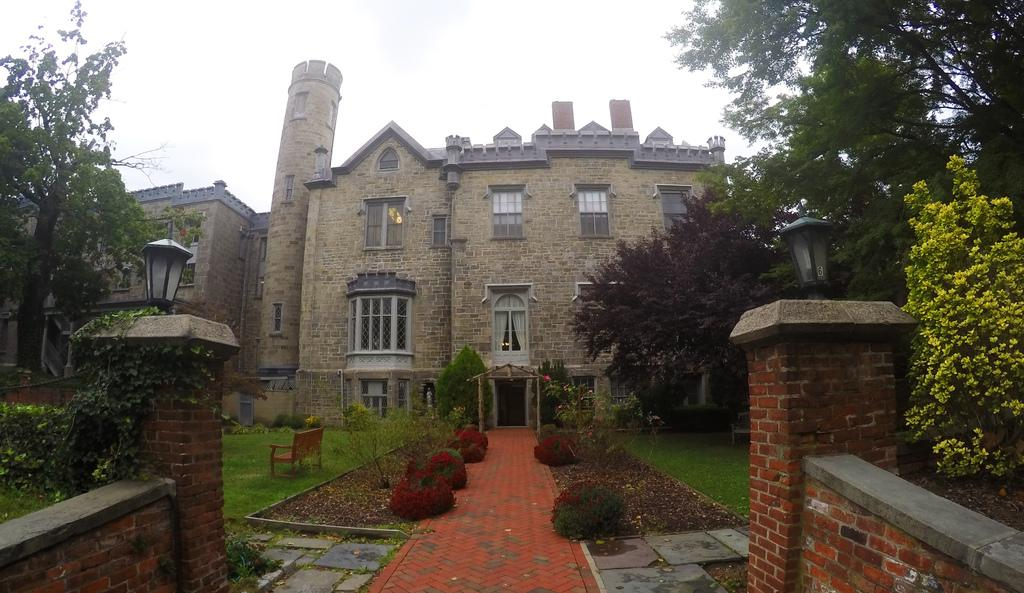What type of structure is present in the image? There is a building in the image. What other natural elements can be seen in the image? There are trees in the image. Is there any seating available in the image? Yes, there is a bench in the image. What is visible in the background of the image? The sky is visible in the image. How many times does the comb appear in the image? There is no comb present in the image. 